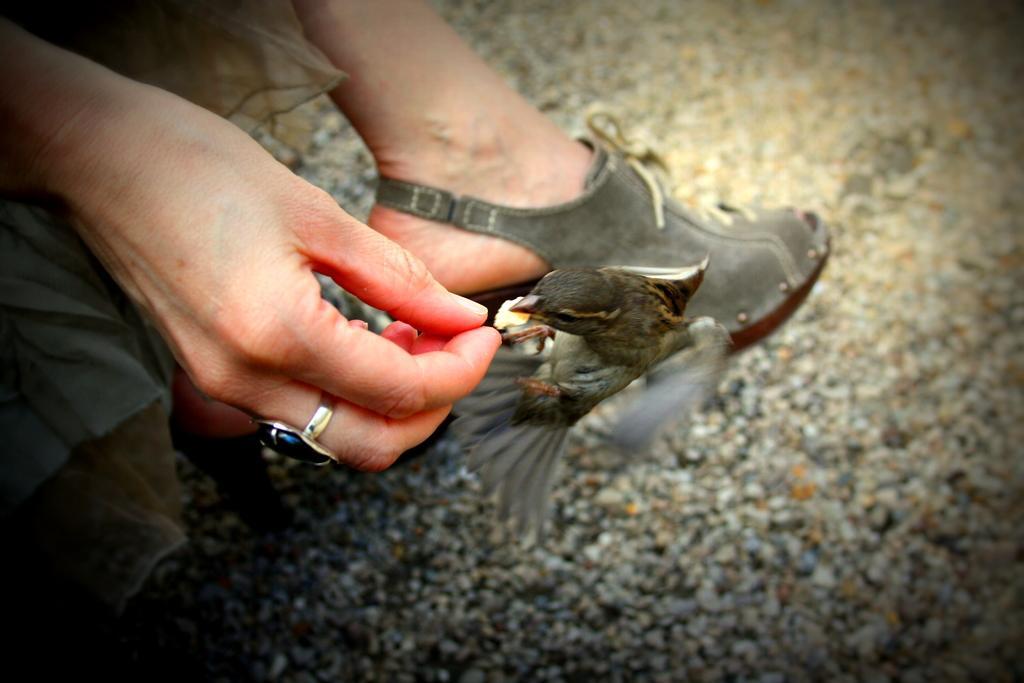In one or two sentences, can you explain what this image depicts? In the image on the left side there is a person hand with ring. In front of the hand there is a bird. Behind the bird there is a leg with footwear. On the ground there are stones. 